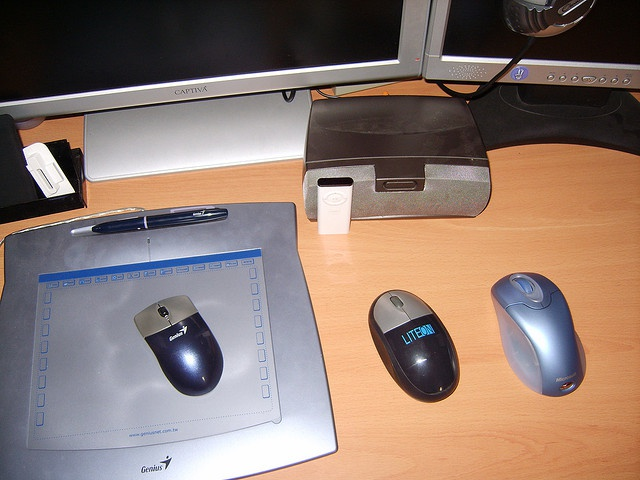Describe the objects in this image and their specific colors. I can see tv in black, darkgray, white, and gray tones, tv in black, darkgray, and gray tones, mouse in black, darkgray, gray, and white tones, mouse in black, darkgray, maroon, and gray tones, and mouse in black, gray, navy, and darkgray tones in this image. 